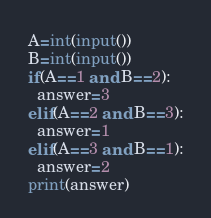Convert code to text. <code><loc_0><loc_0><loc_500><loc_500><_Python_>A=int(input())
B=int(input())
if(A==1 and B==2):
  answer=3
elif(A==2 and B==3):
  answer=1
elif(A==3 and B==1):
  answer=2
print(answer)
</code> 